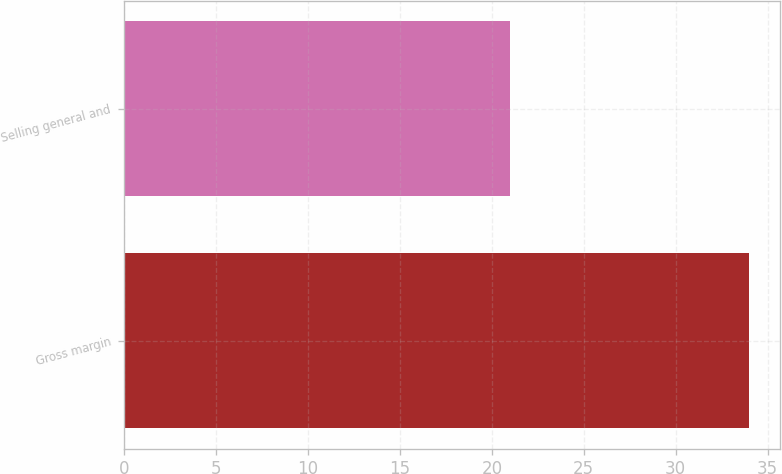<chart> <loc_0><loc_0><loc_500><loc_500><bar_chart><fcel>Gross margin<fcel>Selling general and<nl><fcel>34<fcel>21<nl></chart> 